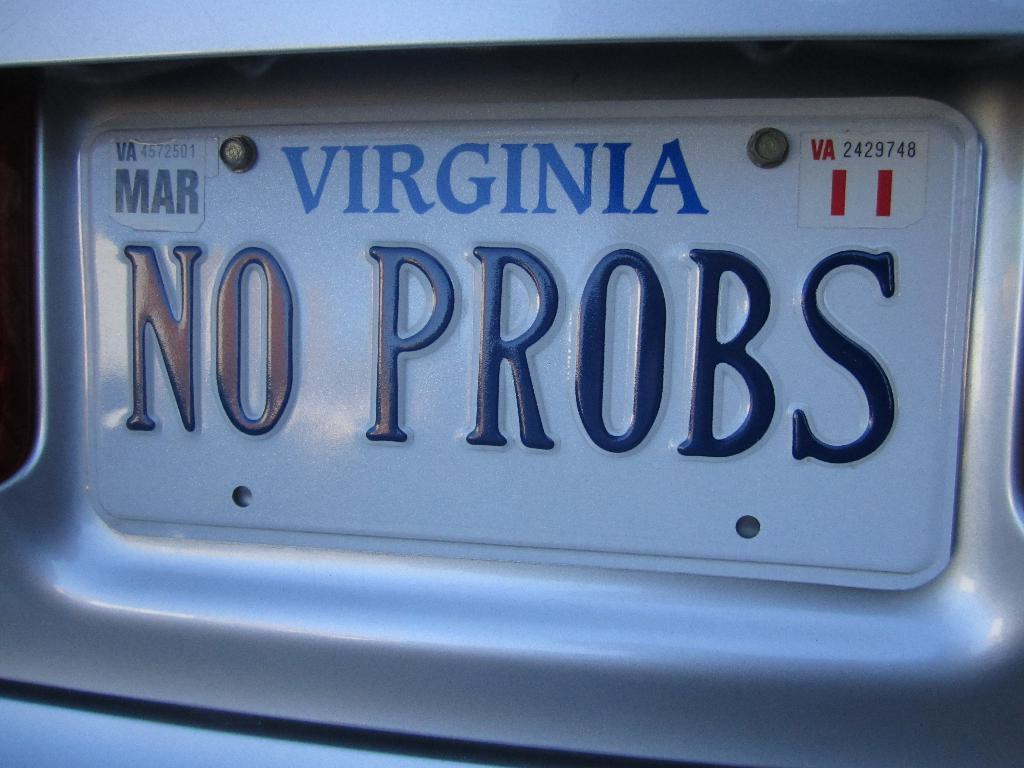<image>
Present a compact description of the photo's key features. A No Probs license plate that is from Virginia 